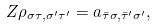Convert formula to latex. <formula><loc_0><loc_0><loc_500><loc_500>Z \rho _ { \sigma \tau , \sigma ^ { \prime } \tau ^ { \prime } } = a _ { \bar { \tau } \sigma , \bar { \tau } ^ { \prime } \sigma ^ { \prime } } ,</formula> 